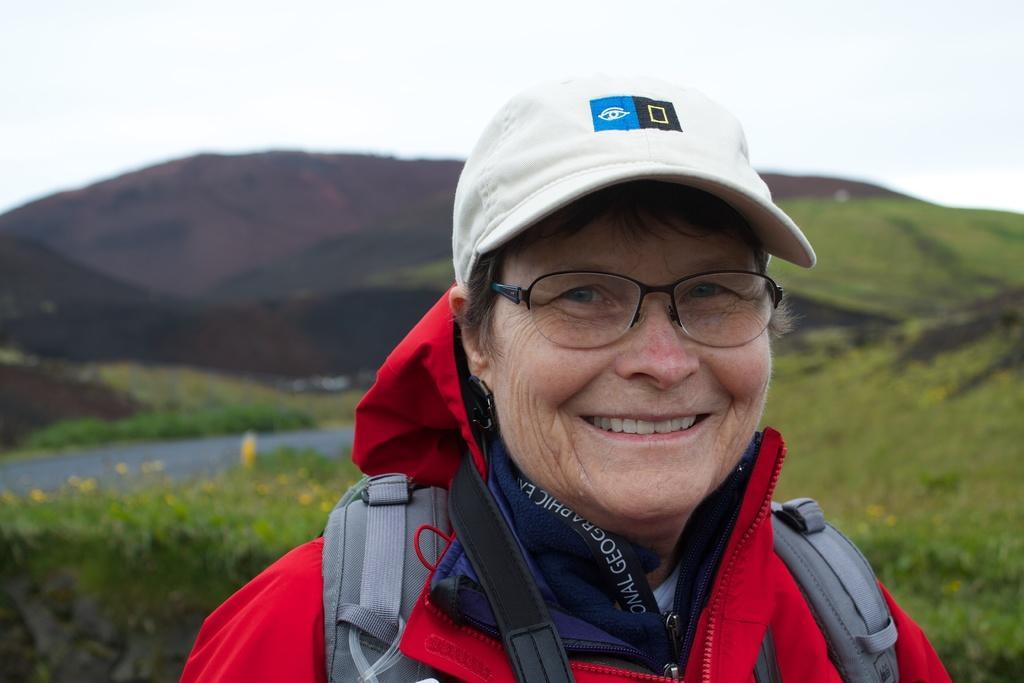Can you describe this image briefly? In this picture there is a woman wearing red dress,backpack and a cap and there is greenery behind her and there are mountains in the background. 